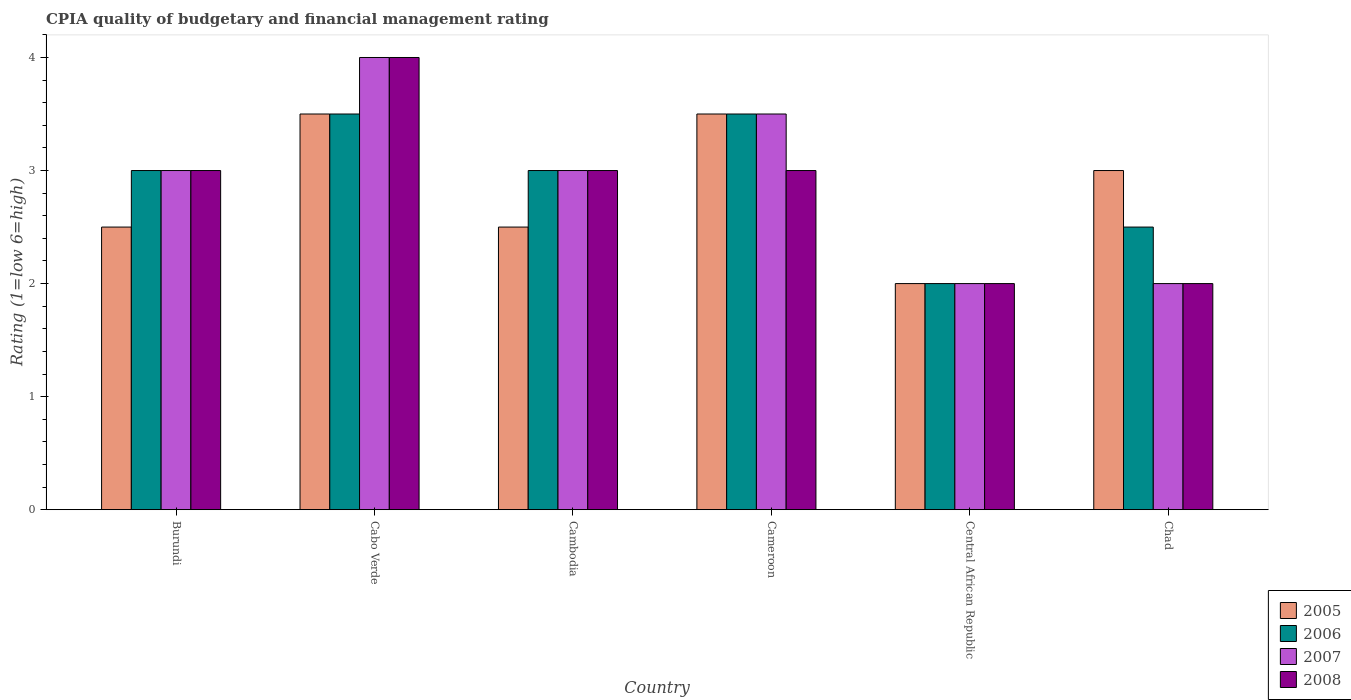How many different coloured bars are there?
Provide a succinct answer. 4. How many bars are there on the 2nd tick from the left?
Keep it short and to the point. 4. What is the label of the 6th group of bars from the left?
Your response must be concise. Chad. In how many cases, is the number of bars for a given country not equal to the number of legend labels?
Your answer should be compact. 0. What is the CPIA rating in 2005 in Burundi?
Your response must be concise. 2.5. Across all countries, what is the minimum CPIA rating in 2006?
Offer a terse response. 2. In which country was the CPIA rating in 2006 maximum?
Your response must be concise. Cabo Verde. In which country was the CPIA rating in 2008 minimum?
Offer a very short reply. Central African Republic. What is the total CPIA rating in 2005 in the graph?
Your response must be concise. 17. What is the difference between the CPIA rating in 2006 in Burundi and that in Cameroon?
Provide a succinct answer. -0.5. What is the difference between the CPIA rating in 2006 in Burundi and the CPIA rating in 2005 in Cabo Verde?
Keep it short and to the point. -0.5. What is the average CPIA rating in 2008 per country?
Your response must be concise. 2.83. What is the difference between the CPIA rating of/in 2007 and CPIA rating of/in 2008 in Central African Republic?
Your response must be concise. 0. What is the ratio of the CPIA rating in 2005 in Cabo Verde to that in Chad?
Give a very brief answer. 1.17. Is the difference between the CPIA rating in 2007 in Cameroon and Chad greater than the difference between the CPIA rating in 2008 in Cameroon and Chad?
Ensure brevity in your answer.  Yes. In how many countries, is the CPIA rating in 2005 greater than the average CPIA rating in 2005 taken over all countries?
Your response must be concise. 3. What does the 1st bar from the left in Burundi represents?
Your answer should be very brief. 2005. What does the 2nd bar from the right in Burundi represents?
Provide a succinct answer. 2007. How many countries are there in the graph?
Provide a succinct answer. 6. Are the values on the major ticks of Y-axis written in scientific E-notation?
Offer a terse response. No. Does the graph contain any zero values?
Offer a terse response. No. What is the title of the graph?
Your answer should be very brief. CPIA quality of budgetary and financial management rating. Does "1961" appear as one of the legend labels in the graph?
Your response must be concise. No. What is the Rating (1=low 6=high) in 2005 in Burundi?
Provide a succinct answer. 2.5. What is the Rating (1=low 6=high) in 2005 in Cabo Verde?
Your response must be concise. 3.5. What is the Rating (1=low 6=high) of 2006 in Cabo Verde?
Make the answer very short. 3.5. What is the Rating (1=low 6=high) of 2008 in Cabo Verde?
Give a very brief answer. 4. What is the Rating (1=low 6=high) of 2006 in Cambodia?
Give a very brief answer. 3. What is the Rating (1=low 6=high) in 2007 in Cambodia?
Offer a terse response. 3. What is the Rating (1=low 6=high) of 2008 in Cambodia?
Provide a short and direct response. 3. What is the Rating (1=low 6=high) of 2005 in Cameroon?
Your answer should be very brief. 3.5. What is the Rating (1=low 6=high) in 2005 in Central African Republic?
Offer a terse response. 2. What is the Rating (1=low 6=high) of 2007 in Central African Republic?
Your answer should be very brief. 2. What is the Rating (1=low 6=high) of 2005 in Chad?
Offer a very short reply. 3. What is the Rating (1=low 6=high) of 2006 in Chad?
Your answer should be very brief. 2.5. What is the Rating (1=low 6=high) of 2007 in Chad?
Make the answer very short. 2. Across all countries, what is the maximum Rating (1=low 6=high) in 2007?
Offer a very short reply. 4. Across all countries, what is the minimum Rating (1=low 6=high) of 2006?
Offer a very short reply. 2. Across all countries, what is the minimum Rating (1=low 6=high) in 2007?
Your answer should be compact. 2. Across all countries, what is the minimum Rating (1=low 6=high) of 2008?
Your response must be concise. 2. What is the total Rating (1=low 6=high) in 2005 in the graph?
Ensure brevity in your answer.  17. What is the total Rating (1=low 6=high) in 2007 in the graph?
Provide a succinct answer. 17.5. What is the difference between the Rating (1=low 6=high) in 2005 in Burundi and that in Cabo Verde?
Your answer should be very brief. -1. What is the difference between the Rating (1=low 6=high) in 2006 in Burundi and that in Cabo Verde?
Give a very brief answer. -0.5. What is the difference between the Rating (1=low 6=high) of 2007 in Burundi and that in Cambodia?
Your answer should be very brief. 0. What is the difference between the Rating (1=low 6=high) in 2008 in Burundi and that in Cameroon?
Keep it short and to the point. 0. What is the difference between the Rating (1=low 6=high) of 2005 in Burundi and that in Central African Republic?
Your answer should be very brief. 0.5. What is the difference between the Rating (1=low 6=high) in 2006 in Burundi and that in Central African Republic?
Give a very brief answer. 1. What is the difference between the Rating (1=low 6=high) in 2007 in Burundi and that in Central African Republic?
Your answer should be compact. 1. What is the difference between the Rating (1=low 6=high) of 2008 in Burundi and that in Central African Republic?
Your response must be concise. 1. What is the difference between the Rating (1=low 6=high) of 2005 in Burundi and that in Chad?
Your answer should be compact. -0.5. What is the difference between the Rating (1=low 6=high) of 2006 in Cabo Verde and that in Cambodia?
Ensure brevity in your answer.  0.5. What is the difference between the Rating (1=low 6=high) in 2005 in Cabo Verde and that in Cameroon?
Ensure brevity in your answer.  0. What is the difference between the Rating (1=low 6=high) in 2007 in Cabo Verde and that in Cameroon?
Offer a very short reply. 0.5. What is the difference between the Rating (1=low 6=high) of 2008 in Cabo Verde and that in Cameroon?
Ensure brevity in your answer.  1. What is the difference between the Rating (1=low 6=high) in 2005 in Cabo Verde and that in Central African Republic?
Give a very brief answer. 1.5. What is the difference between the Rating (1=low 6=high) of 2006 in Cabo Verde and that in Central African Republic?
Provide a succinct answer. 1.5. What is the difference between the Rating (1=low 6=high) of 2005 in Cambodia and that in Cameroon?
Your answer should be compact. -1. What is the difference between the Rating (1=low 6=high) in 2006 in Cambodia and that in Cameroon?
Offer a terse response. -0.5. What is the difference between the Rating (1=low 6=high) of 2008 in Cambodia and that in Cameroon?
Offer a very short reply. 0. What is the difference between the Rating (1=low 6=high) of 2005 in Cambodia and that in Central African Republic?
Offer a terse response. 0.5. What is the difference between the Rating (1=low 6=high) of 2006 in Cambodia and that in Central African Republic?
Provide a succinct answer. 1. What is the difference between the Rating (1=low 6=high) in 2007 in Cambodia and that in Central African Republic?
Offer a terse response. 1. What is the difference between the Rating (1=low 6=high) of 2006 in Cambodia and that in Chad?
Your answer should be compact. 0.5. What is the difference between the Rating (1=low 6=high) in 2007 in Cambodia and that in Chad?
Ensure brevity in your answer.  1. What is the difference between the Rating (1=low 6=high) of 2008 in Cambodia and that in Chad?
Offer a very short reply. 1. What is the difference between the Rating (1=low 6=high) of 2006 in Cameroon and that in Central African Republic?
Your answer should be very brief. 1.5. What is the difference between the Rating (1=low 6=high) in 2007 in Cameroon and that in Central African Republic?
Make the answer very short. 1.5. What is the difference between the Rating (1=low 6=high) in 2008 in Cameroon and that in Central African Republic?
Your answer should be compact. 1. What is the difference between the Rating (1=low 6=high) in 2005 in Cameroon and that in Chad?
Your response must be concise. 0.5. What is the difference between the Rating (1=low 6=high) of 2007 in Cameroon and that in Chad?
Make the answer very short. 1.5. What is the difference between the Rating (1=low 6=high) in 2008 in Cameroon and that in Chad?
Your response must be concise. 1. What is the difference between the Rating (1=low 6=high) in 2008 in Central African Republic and that in Chad?
Your answer should be compact. 0. What is the difference between the Rating (1=low 6=high) in 2005 in Burundi and the Rating (1=low 6=high) in 2006 in Cabo Verde?
Provide a short and direct response. -1. What is the difference between the Rating (1=low 6=high) of 2006 in Burundi and the Rating (1=low 6=high) of 2007 in Cabo Verde?
Give a very brief answer. -1. What is the difference between the Rating (1=low 6=high) of 2007 in Burundi and the Rating (1=low 6=high) of 2008 in Cabo Verde?
Your answer should be compact. -1. What is the difference between the Rating (1=low 6=high) of 2005 in Burundi and the Rating (1=low 6=high) of 2007 in Cambodia?
Provide a succinct answer. -0.5. What is the difference between the Rating (1=low 6=high) of 2006 in Burundi and the Rating (1=low 6=high) of 2008 in Cambodia?
Keep it short and to the point. 0. What is the difference between the Rating (1=low 6=high) in 2005 in Burundi and the Rating (1=low 6=high) in 2007 in Cameroon?
Your answer should be very brief. -1. What is the difference between the Rating (1=low 6=high) in 2005 in Burundi and the Rating (1=low 6=high) in 2008 in Cameroon?
Provide a short and direct response. -0.5. What is the difference between the Rating (1=low 6=high) of 2007 in Burundi and the Rating (1=low 6=high) of 2008 in Cameroon?
Offer a terse response. 0. What is the difference between the Rating (1=low 6=high) in 2005 in Burundi and the Rating (1=low 6=high) in 2006 in Central African Republic?
Your answer should be compact. 0.5. What is the difference between the Rating (1=low 6=high) of 2006 in Burundi and the Rating (1=low 6=high) of 2007 in Central African Republic?
Give a very brief answer. 1. What is the difference between the Rating (1=low 6=high) in 2007 in Burundi and the Rating (1=low 6=high) in 2008 in Central African Republic?
Ensure brevity in your answer.  1. What is the difference between the Rating (1=low 6=high) in 2005 in Burundi and the Rating (1=low 6=high) in 2006 in Chad?
Give a very brief answer. 0. What is the difference between the Rating (1=low 6=high) in 2005 in Burundi and the Rating (1=low 6=high) in 2008 in Chad?
Your answer should be very brief. 0.5. What is the difference between the Rating (1=low 6=high) of 2006 in Burundi and the Rating (1=low 6=high) of 2007 in Chad?
Your answer should be very brief. 1. What is the difference between the Rating (1=low 6=high) in 2007 in Burundi and the Rating (1=low 6=high) in 2008 in Chad?
Give a very brief answer. 1. What is the difference between the Rating (1=low 6=high) of 2005 in Cabo Verde and the Rating (1=low 6=high) of 2007 in Cambodia?
Your answer should be very brief. 0.5. What is the difference between the Rating (1=low 6=high) in 2005 in Cabo Verde and the Rating (1=low 6=high) in 2008 in Cambodia?
Provide a succinct answer. 0.5. What is the difference between the Rating (1=low 6=high) of 2006 in Cabo Verde and the Rating (1=low 6=high) of 2007 in Cambodia?
Make the answer very short. 0.5. What is the difference between the Rating (1=low 6=high) in 2007 in Cabo Verde and the Rating (1=low 6=high) in 2008 in Cambodia?
Offer a very short reply. 1. What is the difference between the Rating (1=low 6=high) of 2005 in Cabo Verde and the Rating (1=low 6=high) of 2006 in Cameroon?
Make the answer very short. 0. What is the difference between the Rating (1=low 6=high) in 2005 in Cabo Verde and the Rating (1=low 6=high) in 2007 in Cameroon?
Offer a terse response. 0. What is the difference between the Rating (1=low 6=high) of 2006 in Cabo Verde and the Rating (1=low 6=high) of 2008 in Cameroon?
Provide a short and direct response. 0.5. What is the difference between the Rating (1=low 6=high) in 2007 in Cabo Verde and the Rating (1=low 6=high) in 2008 in Cameroon?
Keep it short and to the point. 1. What is the difference between the Rating (1=low 6=high) of 2005 in Cabo Verde and the Rating (1=low 6=high) of 2006 in Central African Republic?
Your answer should be very brief. 1.5. What is the difference between the Rating (1=low 6=high) of 2005 in Cabo Verde and the Rating (1=low 6=high) of 2007 in Central African Republic?
Ensure brevity in your answer.  1.5. What is the difference between the Rating (1=low 6=high) of 2005 in Cabo Verde and the Rating (1=low 6=high) of 2008 in Central African Republic?
Your answer should be very brief. 1.5. What is the difference between the Rating (1=low 6=high) of 2007 in Cabo Verde and the Rating (1=low 6=high) of 2008 in Central African Republic?
Your answer should be very brief. 2. What is the difference between the Rating (1=low 6=high) of 2006 in Cabo Verde and the Rating (1=low 6=high) of 2007 in Chad?
Provide a succinct answer. 1.5. What is the difference between the Rating (1=low 6=high) in 2006 in Cabo Verde and the Rating (1=low 6=high) in 2008 in Chad?
Offer a very short reply. 1.5. What is the difference between the Rating (1=low 6=high) of 2005 in Cambodia and the Rating (1=low 6=high) of 2007 in Cameroon?
Ensure brevity in your answer.  -1. What is the difference between the Rating (1=low 6=high) in 2006 in Cambodia and the Rating (1=low 6=high) in 2007 in Cameroon?
Give a very brief answer. -0.5. What is the difference between the Rating (1=low 6=high) in 2006 in Cambodia and the Rating (1=low 6=high) in 2008 in Cameroon?
Keep it short and to the point. 0. What is the difference between the Rating (1=low 6=high) of 2007 in Cambodia and the Rating (1=low 6=high) of 2008 in Cameroon?
Give a very brief answer. 0. What is the difference between the Rating (1=low 6=high) in 2005 in Cambodia and the Rating (1=low 6=high) in 2008 in Central African Republic?
Your response must be concise. 0.5. What is the difference between the Rating (1=low 6=high) in 2007 in Cambodia and the Rating (1=low 6=high) in 2008 in Central African Republic?
Ensure brevity in your answer.  1. What is the difference between the Rating (1=low 6=high) in 2005 in Cambodia and the Rating (1=low 6=high) in 2006 in Chad?
Make the answer very short. 0. What is the difference between the Rating (1=low 6=high) in 2005 in Cambodia and the Rating (1=low 6=high) in 2008 in Chad?
Your answer should be very brief. 0.5. What is the difference between the Rating (1=low 6=high) of 2006 in Cambodia and the Rating (1=low 6=high) of 2007 in Chad?
Ensure brevity in your answer.  1. What is the difference between the Rating (1=low 6=high) in 2006 in Cambodia and the Rating (1=low 6=high) in 2008 in Chad?
Provide a succinct answer. 1. What is the difference between the Rating (1=low 6=high) of 2005 in Cameroon and the Rating (1=low 6=high) of 2006 in Central African Republic?
Offer a terse response. 1.5. What is the difference between the Rating (1=low 6=high) of 2005 in Cameroon and the Rating (1=low 6=high) of 2007 in Central African Republic?
Offer a very short reply. 1.5. What is the difference between the Rating (1=low 6=high) of 2005 in Cameroon and the Rating (1=low 6=high) of 2008 in Central African Republic?
Offer a terse response. 1.5. What is the difference between the Rating (1=low 6=high) in 2006 in Cameroon and the Rating (1=low 6=high) in 2007 in Central African Republic?
Your answer should be compact. 1.5. What is the difference between the Rating (1=low 6=high) in 2007 in Cameroon and the Rating (1=low 6=high) in 2008 in Central African Republic?
Offer a very short reply. 1.5. What is the difference between the Rating (1=low 6=high) of 2005 in Cameroon and the Rating (1=low 6=high) of 2006 in Chad?
Keep it short and to the point. 1. What is the difference between the Rating (1=low 6=high) in 2005 in Cameroon and the Rating (1=low 6=high) in 2007 in Chad?
Your answer should be compact. 1.5. What is the difference between the Rating (1=low 6=high) of 2006 in Cameroon and the Rating (1=low 6=high) of 2008 in Chad?
Keep it short and to the point. 1.5. What is the difference between the Rating (1=low 6=high) of 2005 in Central African Republic and the Rating (1=low 6=high) of 2007 in Chad?
Ensure brevity in your answer.  0. What is the difference between the Rating (1=low 6=high) of 2005 in Central African Republic and the Rating (1=low 6=high) of 2008 in Chad?
Your answer should be compact. 0. What is the difference between the Rating (1=low 6=high) of 2006 in Central African Republic and the Rating (1=low 6=high) of 2007 in Chad?
Offer a terse response. 0. What is the difference between the Rating (1=low 6=high) in 2006 in Central African Republic and the Rating (1=low 6=high) in 2008 in Chad?
Your response must be concise. 0. What is the average Rating (1=low 6=high) in 2005 per country?
Offer a very short reply. 2.83. What is the average Rating (1=low 6=high) in 2006 per country?
Your answer should be compact. 2.92. What is the average Rating (1=low 6=high) of 2007 per country?
Keep it short and to the point. 2.92. What is the average Rating (1=low 6=high) in 2008 per country?
Provide a short and direct response. 2.83. What is the difference between the Rating (1=low 6=high) in 2005 and Rating (1=low 6=high) in 2006 in Burundi?
Make the answer very short. -0.5. What is the difference between the Rating (1=low 6=high) in 2006 and Rating (1=low 6=high) in 2007 in Burundi?
Your answer should be compact. 0. What is the difference between the Rating (1=low 6=high) in 2007 and Rating (1=low 6=high) in 2008 in Burundi?
Your response must be concise. 0. What is the difference between the Rating (1=low 6=high) of 2005 and Rating (1=low 6=high) of 2006 in Cabo Verde?
Offer a terse response. 0. What is the difference between the Rating (1=low 6=high) of 2005 and Rating (1=low 6=high) of 2008 in Cabo Verde?
Your response must be concise. -0.5. What is the difference between the Rating (1=low 6=high) in 2006 and Rating (1=low 6=high) in 2007 in Cabo Verde?
Give a very brief answer. -0.5. What is the difference between the Rating (1=low 6=high) in 2006 and Rating (1=low 6=high) in 2008 in Cabo Verde?
Your answer should be compact. -0.5. What is the difference between the Rating (1=low 6=high) in 2005 and Rating (1=low 6=high) in 2007 in Cambodia?
Provide a short and direct response. -0.5. What is the difference between the Rating (1=low 6=high) in 2005 and Rating (1=low 6=high) in 2008 in Cambodia?
Make the answer very short. -0.5. What is the difference between the Rating (1=low 6=high) of 2006 and Rating (1=low 6=high) of 2007 in Cameroon?
Make the answer very short. 0. What is the difference between the Rating (1=low 6=high) in 2006 and Rating (1=low 6=high) in 2008 in Cameroon?
Ensure brevity in your answer.  0.5. What is the difference between the Rating (1=low 6=high) of 2007 and Rating (1=low 6=high) of 2008 in Cameroon?
Your answer should be compact. 0.5. What is the difference between the Rating (1=low 6=high) of 2005 and Rating (1=low 6=high) of 2007 in Central African Republic?
Give a very brief answer. 0. What is the difference between the Rating (1=low 6=high) of 2006 and Rating (1=low 6=high) of 2007 in Central African Republic?
Ensure brevity in your answer.  0. What is the difference between the Rating (1=low 6=high) in 2005 and Rating (1=low 6=high) in 2006 in Chad?
Give a very brief answer. 0.5. What is the difference between the Rating (1=low 6=high) of 2005 and Rating (1=low 6=high) of 2008 in Chad?
Ensure brevity in your answer.  1. What is the difference between the Rating (1=low 6=high) of 2006 and Rating (1=low 6=high) of 2007 in Chad?
Give a very brief answer. 0.5. What is the difference between the Rating (1=low 6=high) of 2006 and Rating (1=low 6=high) of 2008 in Chad?
Give a very brief answer. 0.5. What is the difference between the Rating (1=low 6=high) of 2007 and Rating (1=low 6=high) of 2008 in Chad?
Make the answer very short. 0. What is the ratio of the Rating (1=low 6=high) of 2005 in Burundi to that in Cabo Verde?
Ensure brevity in your answer.  0.71. What is the ratio of the Rating (1=low 6=high) in 2006 in Burundi to that in Cabo Verde?
Your answer should be very brief. 0.86. What is the ratio of the Rating (1=low 6=high) of 2007 in Burundi to that in Cabo Verde?
Provide a short and direct response. 0.75. What is the ratio of the Rating (1=low 6=high) in 2008 in Burundi to that in Cabo Verde?
Provide a succinct answer. 0.75. What is the ratio of the Rating (1=low 6=high) of 2007 in Burundi to that in Cambodia?
Your answer should be compact. 1. What is the ratio of the Rating (1=low 6=high) of 2008 in Burundi to that in Cambodia?
Make the answer very short. 1. What is the ratio of the Rating (1=low 6=high) in 2005 in Burundi to that in Central African Republic?
Your answer should be compact. 1.25. What is the ratio of the Rating (1=low 6=high) in 2008 in Burundi to that in Chad?
Provide a short and direct response. 1.5. What is the ratio of the Rating (1=low 6=high) of 2005 in Cabo Verde to that in Cambodia?
Ensure brevity in your answer.  1.4. What is the ratio of the Rating (1=low 6=high) of 2006 in Cabo Verde to that in Cambodia?
Offer a very short reply. 1.17. What is the ratio of the Rating (1=low 6=high) in 2006 in Cabo Verde to that in Cameroon?
Ensure brevity in your answer.  1. What is the ratio of the Rating (1=low 6=high) of 2007 in Cabo Verde to that in Cameroon?
Ensure brevity in your answer.  1.14. What is the ratio of the Rating (1=low 6=high) of 2005 in Cabo Verde to that in Central African Republic?
Provide a short and direct response. 1.75. What is the ratio of the Rating (1=low 6=high) of 2005 in Cabo Verde to that in Chad?
Your answer should be compact. 1.17. What is the ratio of the Rating (1=low 6=high) of 2006 in Cabo Verde to that in Chad?
Offer a very short reply. 1.4. What is the ratio of the Rating (1=low 6=high) of 2007 in Cabo Verde to that in Chad?
Provide a short and direct response. 2. What is the ratio of the Rating (1=low 6=high) of 2006 in Cambodia to that in Cameroon?
Your response must be concise. 0.86. What is the ratio of the Rating (1=low 6=high) in 2008 in Cambodia to that in Cameroon?
Offer a terse response. 1. What is the ratio of the Rating (1=low 6=high) of 2008 in Cambodia to that in Central African Republic?
Give a very brief answer. 1.5. What is the ratio of the Rating (1=low 6=high) of 2005 in Cambodia to that in Chad?
Offer a very short reply. 0.83. What is the ratio of the Rating (1=low 6=high) in 2007 in Cambodia to that in Chad?
Provide a short and direct response. 1.5. What is the ratio of the Rating (1=low 6=high) in 2005 in Cameroon to that in Central African Republic?
Your response must be concise. 1.75. What is the ratio of the Rating (1=low 6=high) of 2006 in Cameroon to that in Central African Republic?
Your response must be concise. 1.75. What is the ratio of the Rating (1=low 6=high) of 2006 in Cameroon to that in Chad?
Offer a very short reply. 1.4. What is the ratio of the Rating (1=low 6=high) of 2007 in Cameroon to that in Chad?
Keep it short and to the point. 1.75. What is the ratio of the Rating (1=low 6=high) of 2008 in Cameroon to that in Chad?
Ensure brevity in your answer.  1.5. What is the ratio of the Rating (1=low 6=high) in 2005 in Central African Republic to that in Chad?
Ensure brevity in your answer.  0.67. What is the ratio of the Rating (1=low 6=high) in 2006 in Central African Republic to that in Chad?
Keep it short and to the point. 0.8. What is the ratio of the Rating (1=low 6=high) in 2007 in Central African Republic to that in Chad?
Offer a very short reply. 1. What is the difference between the highest and the second highest Rating (1=low 6=high) in 2005?
Your answer should be compact. 0. What is the difference between the highest and the second highest Rating (1=low 6=high) of 2006?
Your response must be concise. 0. What is the difference between the highest and the second highest Rating (1=low 6=high) in 2008?
Offer a very short reply. 1. What is the difference between the highest and the lowest Rating (1=low 6=high) in 2005?
Make the answer very short. 1.5. What is the difference between the highest and the lowest Rating (1=low 6=high) in 2006?
Your answer should be very brief. 1.5. What is the difference between the highest and the lowest Rating (1=low 6=high) of 2007?
Provide a succinct answer. 2. What is the difference between the highest and the lowest Rating (1=low 6=high) in 2008?
Your answer should be compact. 2. 